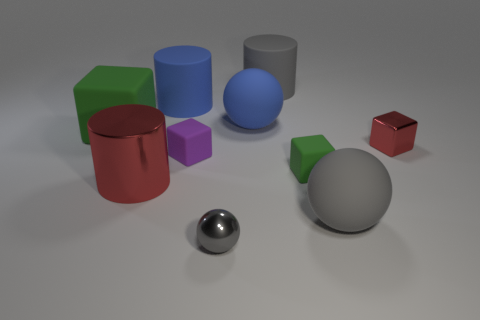Subtract all balls. How many objects are left? 7 Subtract 0 red balls. How many objects are left? 10 Subtract all tiny green matte things. Subtract all tiny green metal spheres. How many objects are left? 9 Add 6 big red objects. How many big red objects are left? 7 Add 6 small green things. How many small green things exist? 7 